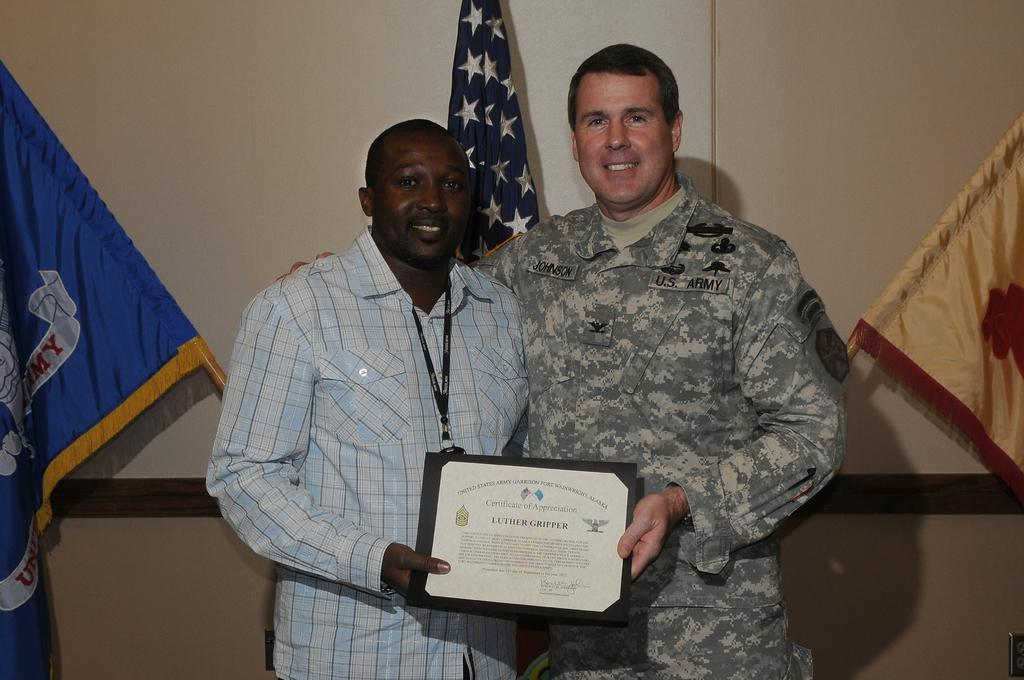How many people are in the image? There are two people standing in the image. What are the people holding in the image? The people are holding a memorandum. Can you describe the clothing of the man on the right? The man on the right is wearing a uniform. What can be seen in the background of the image? There are flags and a wall in the background of the image. What type of hair is visible on the banana in the image? There is no banana present in the image, and therefore no hair can be observed on it. 